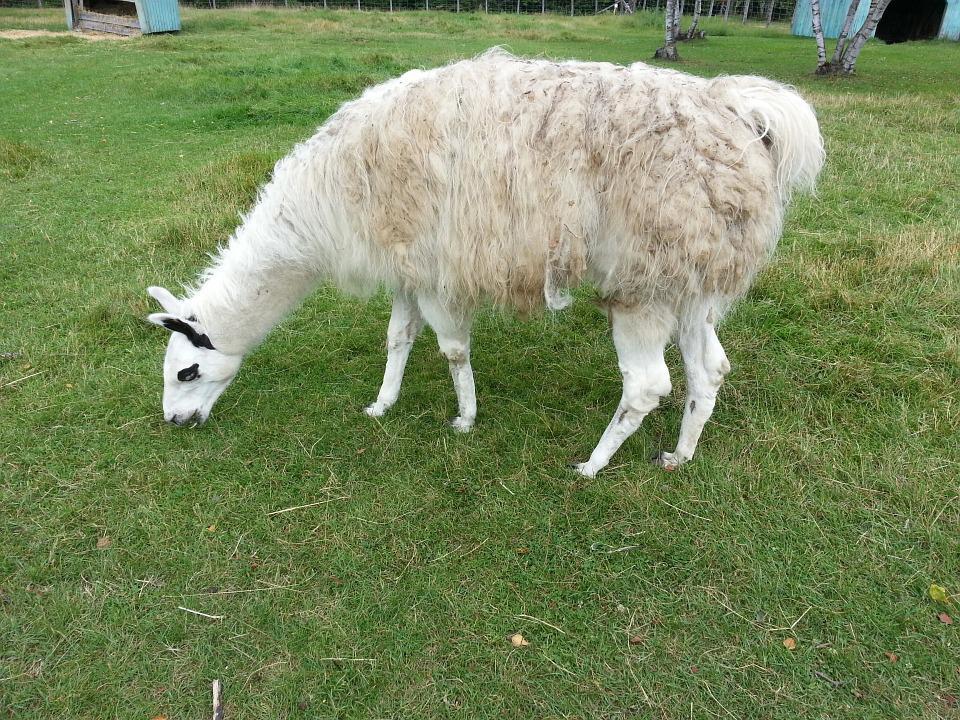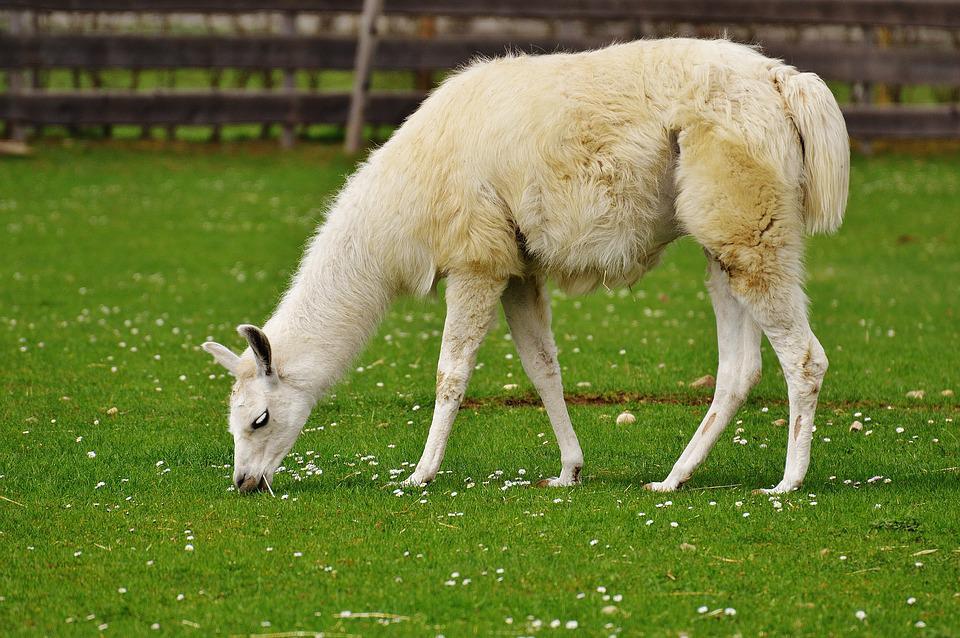The first image is the image on the left, the second image is the image on the right. Given the left and right images, does the statement "The left and right image contains the same number of Llamas facing the same direction." hold true? Answer yes or no. Yes. The first image is the image on the left, the second image is the image on the right. Considering the images on both sides, is "Each image contains a single llama, no llama looks straight at the camera, and the llamas on the left and right share similar fur coloring and body poses." valid? Answer yes or no. Yes. 